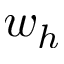Convert formula to latex. <formula><loc_0><loc_0><loc_500><loc_500>w _ { h }</formula> 